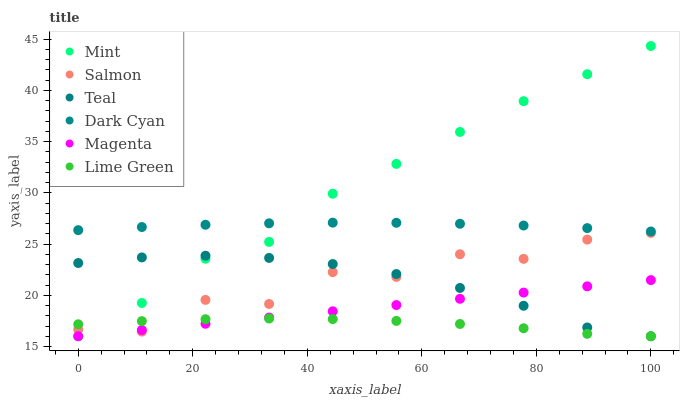Does Lime Green have the minimum area under the curve?
Answer yes or no. Yes. Does Mint have the maximum area under the curve?
Answer yes or no. Yes. Does Salmon have the minimum area under the curve?
Answer yes or no. No. Does Salmon have the maximum area under the curve?
Answer yes or no. No. Is Magenta the smoothest?
Answer yes or no. Yes. Is Salmon the roughest?
Answer yes or no. Yes. Is Teal the smoothest?
Answer yes or no. No. Is Teal the roughest?
Answer yes or no. No. Does Lime Green have the lowest value?
Answer yes or no. Yes. Does Salmon have the lowest value?
Answer yes or no. No. Does Mint have the highest value?
Answer yes or no. Yes. Does Salmon have the highest value?
Answer yes or no. No. Is Lime Green less than Dark Cyan?
Answer yes or no. Yes. Is Dark Cyan greater than Salmon?
Answer yes or no. Yes. Does Mint intersect Teal?
Answer yes or no. Yes. Is Mint less than Teal?
Answer yes or no. No. Is Mint greater than Teal?
Answer yes or no. No. Does Lime Green intersect Dark Cyan?
Answer yes or no. No. 